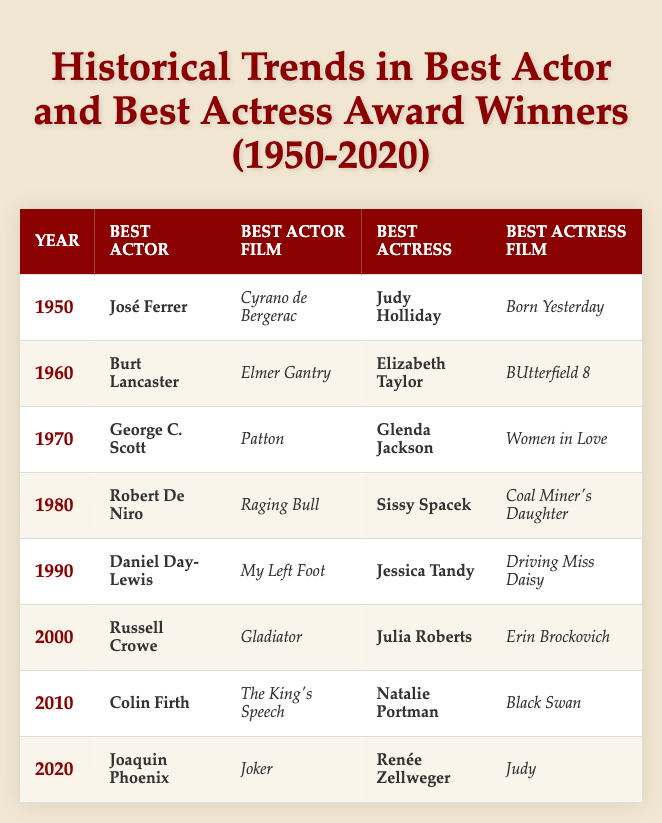What was the winner for Best Actor in 1980? The table shows that the Best Actor winner in 1980 was Robert De Niro.
Answer: Robert De Niro Which actress won the Best Actress award in 1990? According to the table, Jessica Tandy was the Best Actress winner in 1990.
Answer: Jessica Tandy How many times did Elizabeth Taylor win the Best Actress award from 1950 to 2020? The table shows Elizabeth Taylor won Best Actress in 1960 only, so she won a single time during this period.
Answer: 1 Which film won Best Actor in 2000? The table indicates that the film Gladiator was associated with the Best Actor winner Russell Crowe in 2000.
Answer: Gladiator Who was awarded Best Actress in the year 2010? Referring to the table, Natalie Portman won the Best Actress award in 2010.
Answer: Natalie Portman Is there a year when the same person won both Best Actor and Best Actress? By examining the table, there are no entries where the same individual won both awards in the same year.
Answer: No Which actor won the Best Actor award in the most recent year listed in the table? The table reveals that in 2020, Joaquin Phoenix won the Best Actor award.
Answer: Joaquin Phoenix What is the average year for Best Actor winners listed? The years listed for Best Actor winners are 1950, 1960, 1970, 1980, 1990, 2000, 2010, and 2020, totaling 8 entries; their sum is 1960. The average year is 1960/8 = 1975.
Answer: 1975 Was Judy Holliday the first actress to win Best Actress in the table? Based on the table, Judy Holliday was the Best Actress winner first in 1950.
Answer: Yes Which films were associated with the Best Actor winners in the 1970s? The Best Actor winners in the 1970s are George C. Scott for Patton (1970) and Robert De Niro for Raging Bull (1970). Combined, the films are Patton and Raging Bull.
Answer: Patton, Raging Bull How many times did Joaquin Phoenix win the Best Actor award from 1950 to 2020? The table shows Joaquin Phoenix won the Best Actor award in 2020 only, indicating one win for him in this timeframe.
Answer: 1 